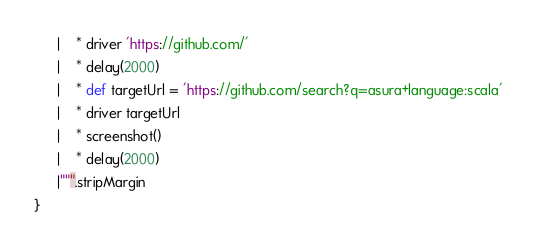Convert code to text. <code><loc_0><loc_0><loc_500><loc_500><_Scala_>      |    * driver 'https://github.com/'
      |    * delay(2000)
      |    * def targetUrl = 'https://github.com/search?q=asura+language:scala'
      |    * driver targetUrl
      |    * screenshot()
      |    * delay(2000)
      |""".stripMargin
}
</code> 